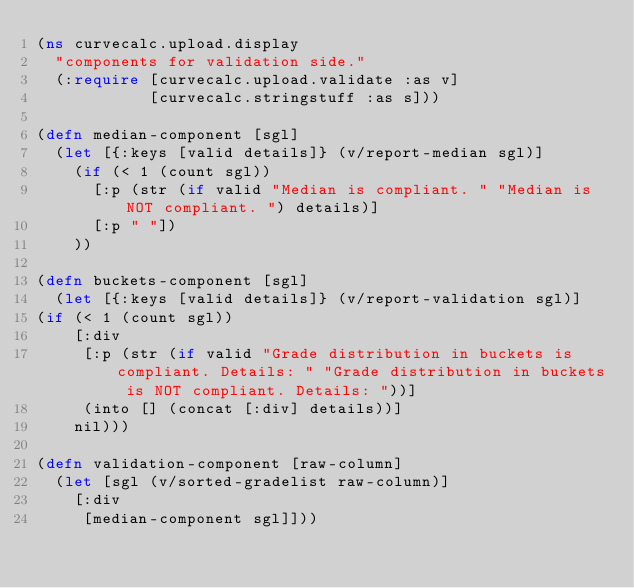Convert code to text. <code><loc_0><loc_0><loc_500><loc_500><_Clojure_>(ns curvecalc.upload.display
  "components for validation side."
  (:require [curvecalc.upload.validate :as v]
            [curvecalc.stringstuff :as s]))

(defn median-component [sgl]
  (let [{:keys [valid details]} (v/report-median sgl)]
    (if (< 1 (count sgl))
      [:p (str (if valid "Median is compliant. " "Median is NOT compliant. ") details)]
      [:p " "])
    ))

(defn buckets-component [sgl]
  (let [{:keys [valid details]} (v/report-validation sgl)]
(if (< 1 (count sgl))
    [:div
     [:p (str (if valid "Grade distribution in buckets is compliant. Details: " "Grade distribution in buckets is NOT compliant. Details: "))]
     (into [] (concat [:div] details))]
    nil)))

(defn validation-component [raw-column]
  (let [sgl (v/sorted-gradelist raw-column)]
    [:div
     [median-component sgl]]))
</code> 